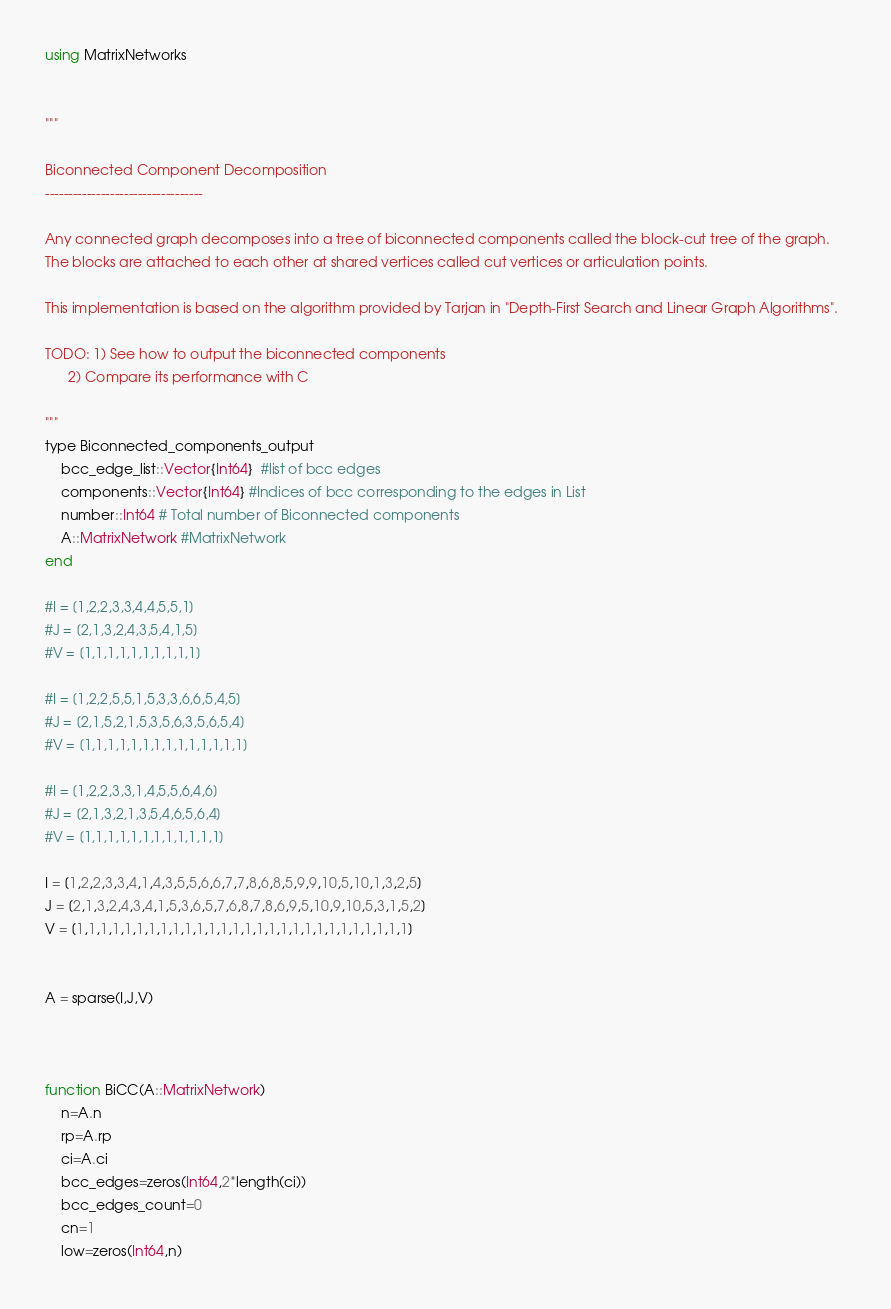<code> <loc_0><loc_0><loc_500><loc_500><_Julia_>
using MatrixNetworks


"""

Biconnected Component Decomposition
----------------------------------

Any connected graph decomposes into a tree of biconnected components called the block-cut tree of the graph. 
The blocks are attached to each other at shared vertices called cut vertices or articulation points.

This implementation is based on the algorithm provided by Tarjan in "Depth-First Search and Linear Graph Algorithms".  

TODO: 1) See how to output the biconnected components
      2) Compare its performance with C

"""
type Biconnected_components_output
    bcc_edge_list::Vector{Int64}  #list of bcc edges
    components::Vector{Int64} #Indices of bcc corresponding to the edges in List
    number::Int64 # Total number of Biconnected components
    A::MatrixNetwork #MatrixNetwork
end

#I = [1,2,2,3,3,4,4,5,5,1]
#J = [2,1,3,2,4,3,5,4,1,5]
#V = [1,1,1,1,1,1,1,1,1,1]

#I = [1,2,2,5,5,1,5,3,3,6,6,5,4,5]
#J = [2,1,5,2,1,5,3,5,6,3,5,6,5,4]
#V = [1,1,1,1,1,1,1,1,1,1,1,1,1,1]

#I = [1,2,2,3,3,1,4,5,5,6,4,6]
#J = [2,1,3,2,1,3,5,4,6,5,6,4]
#V = [1,1,1,1,1,1,1,1,1,1,1,1]

I = [1,2,2,3,3,4,1,4,3,5,5,6,6,7,7,8,6,8,5,9,9,10,5,10,1,3,2,5]
J = [2,1,3,2,4,3,4,1,5,3,6,5,7,6,8,7,8,6,9,5,10,9,10,5,3,1,5,2]
V = [1,1,1,1,1,1,1,1,1,1,1,1,1,1,1,1,1,1,1,1,1,1,1,1,1,1,1,1]


A = sparse(I,J,V)



function BiCC(A::MatrixNetwork)
    n=A.n
    rp=A.rp
    ci=A.ci
    bcc_edges=zeros(Int64,2*length(ci))
    bcc_edges_count=0
    cn=1
    low=zeros(Int64,n)</code> 